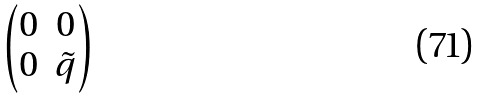Convert formula to latex. <formula><loc_0><loc_0><loc_500><loc_500>\begin{pmatrix} 0 & 0 \\ 0 & \tilde { q } \end{pmatrix}</formula> 